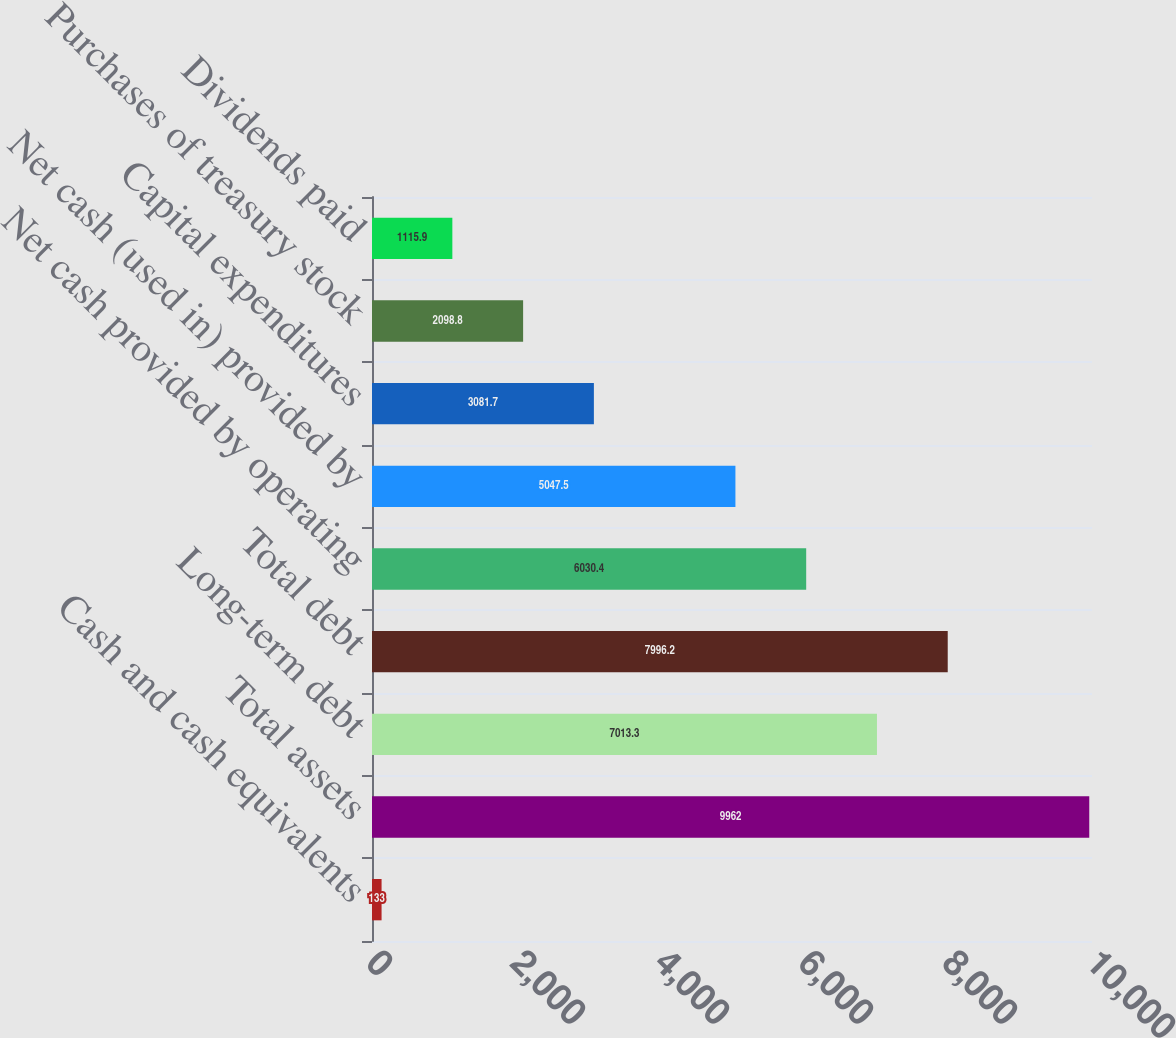Convert chart to OTSL. <chart><loc_0><loc_0><loc_500><loc_500><bar_chart><fcel>Cash and cash equivalents<fcel>Total assets<fcel>Long-term debt<fcel>Total debt<fcel>Net cash provided by operating<fcel>Net cash (used in) provided by<fcel>Capital expenditures<fcel>Purchases of treasury stock<fcel>Dividends paid<nl><fcel>133<fcel>9962<fcel>7013.3<fcel>7996.2<fcel>6030.4<fcel>5047.5<fcel>3081.7<fcel>2098.8<fcel>1115.9<nl></chart> 